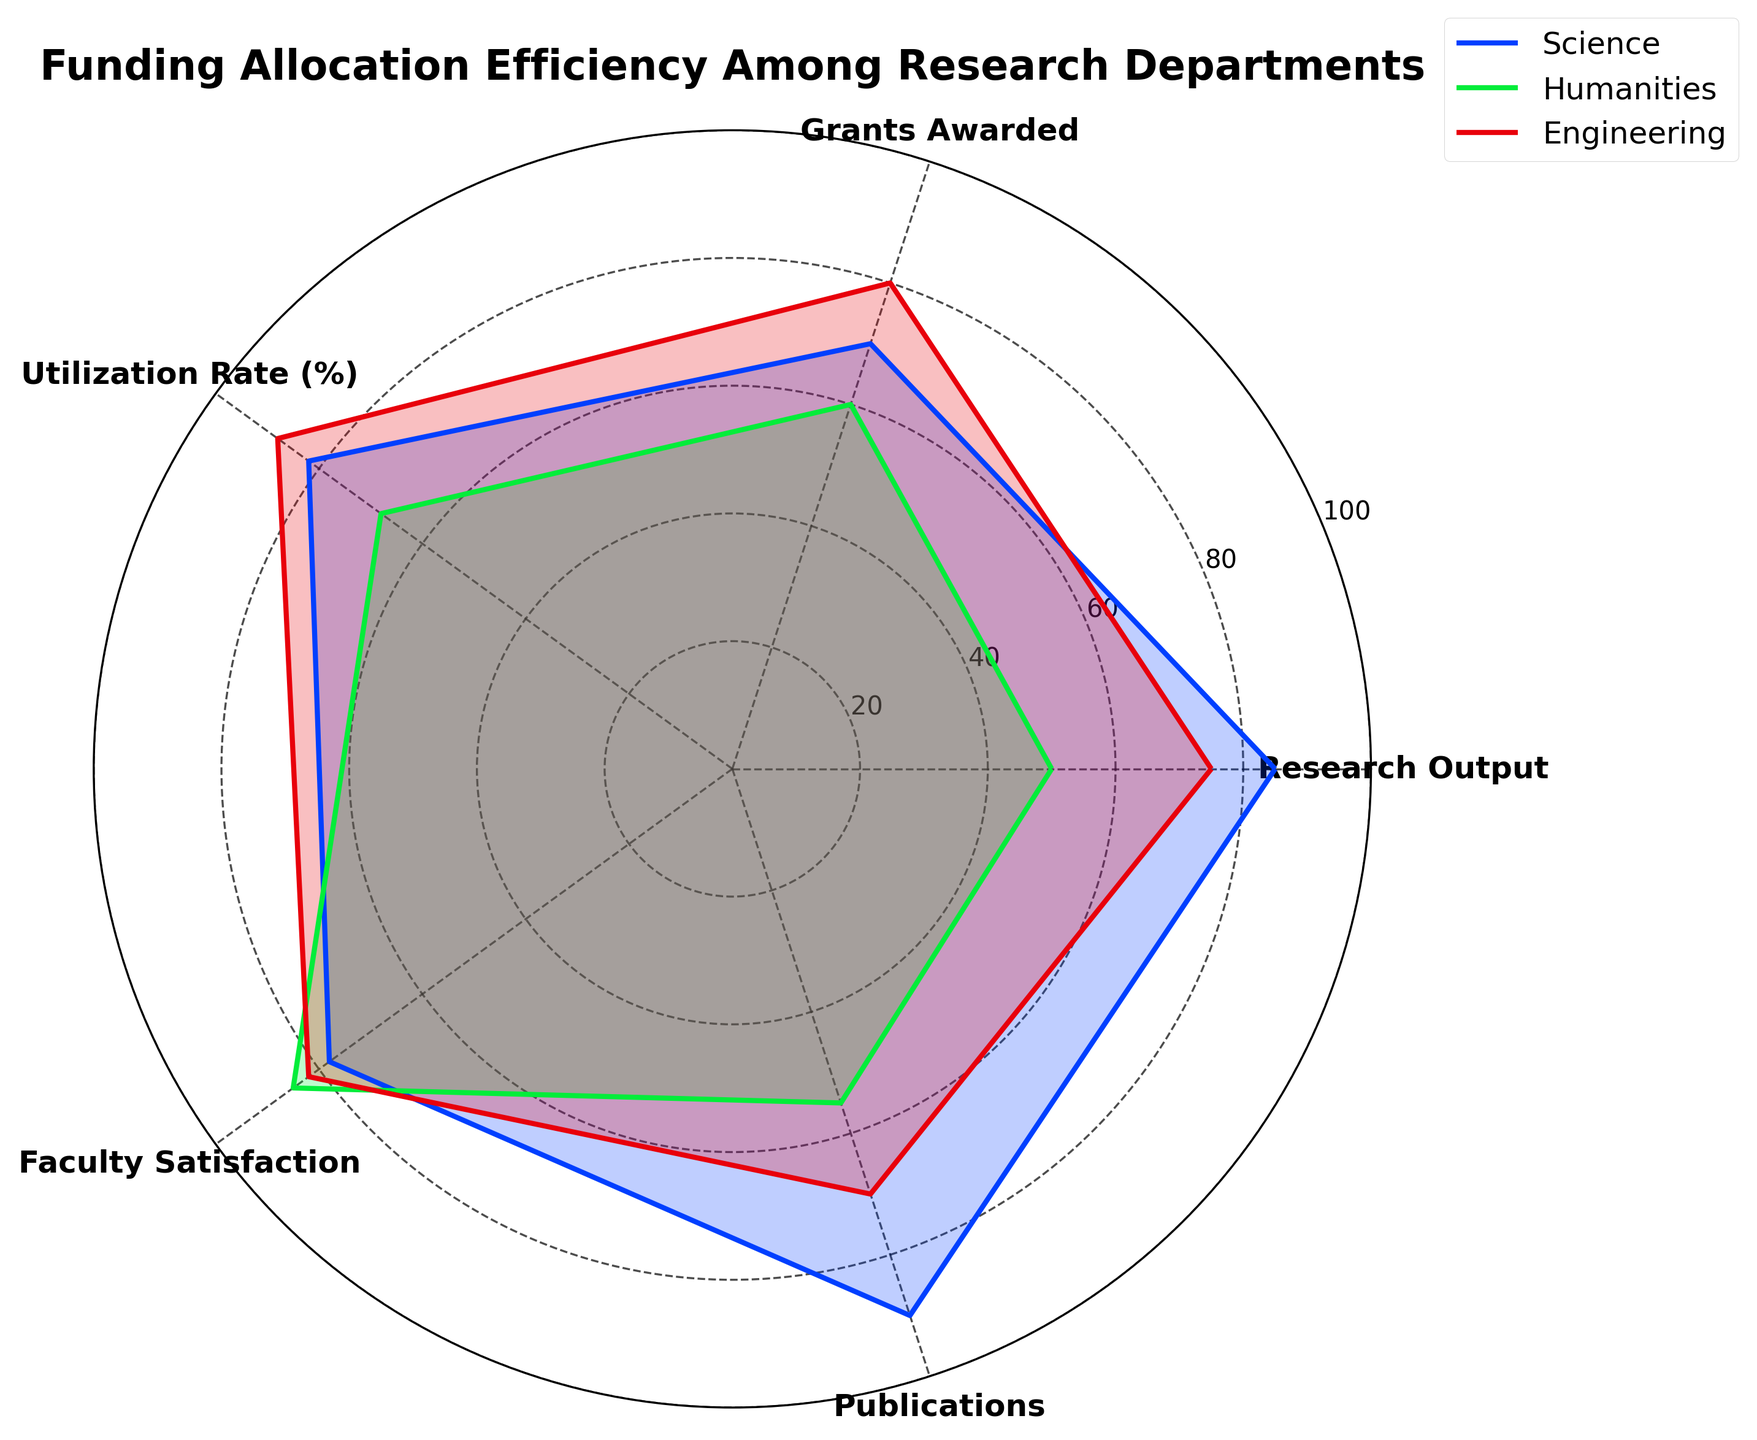What is the title of the plot? The title is located at the top of the radar chart and serves as a summary of what the chart represents.
Answer: Funding Allocation Efficiency Among Research Departments What does the 'Science' department score for 'Research Output'? Locate the 'Science' department's path on the radar chart and find the value for 'Research Output'.
Answer: 85 Which department has the highest 'Utilization Rate (%)'? Compare the 'Utilization Rate (%)' values for the Science, Humanities, and Engineering departments by looking at the corresponding points on the radar chart.
Answer: Engineering What is the difference in 'Grants Awarded' between the 'Humanities' and 'Engineering' departments? Determine the 'Grants Awarded' values for both departments and subtract one from the other: Humanities (60) and Engineering (80).
Answer: 20 How do the 'Faculty Satisfaction' scores compare between 'Science' and 'Humanities'? Compare the 'Faculty Satisfaction' scores for both departments by locating the respective points on the radar chart: Science (78) and Humanities (85).
Answer: Humanities is higher What is the range of 'Publications' among the three departments? Identify the minimum and maximum 'Publications' values from the radar chart: Science (90), Humanities (55), and Engineering (70). Subtract the minimum from the maximum.
Answer: 35 Which department demonstrates the most balanced allocation across all categories? Observe the shape and spread of each department's polygon. The department with the least variation among categories is considered the most balanced.
Answer: Science What is the sum of the 'Faculty Satisfaction' and 'Publications' for the 'Engineering' department? Find the 'Faculty Satisfaction' (82) and 'Publications' (70) values for the Engineering department and sum them up.
Answer: 152 Which department has the lowest score in 'Research Output'? Compare the 'Research Output' scores for the departments: Science (85), Humanities (50), and Engineering (75).
Answer: Humanities For which category does the 'Humanities' department have the highest score relative to other categories? Compare all the scores for the 'Humanities' department, finding the highest value among them: Research Output (50), Grants Awarded (60), Utilization Rate (%) (68), Faculty Satisfaction (85), and Publications (55).
Answer: Faculty Satisfaction 